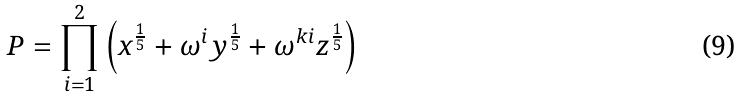Convert formula to latex. <formula><loc_0><loc_0><loc_500><loc_500>P = \prod _ { i = 1 } ^ { 2 } \left ( x ^ { \frac { 1 } { 5 } } + \omega ^ { i } y ^ { \frac { 1 } { 5 } } + \omega ^ { k i } z ^ { \frac { 1 } { 5 } } \right )</formula> 